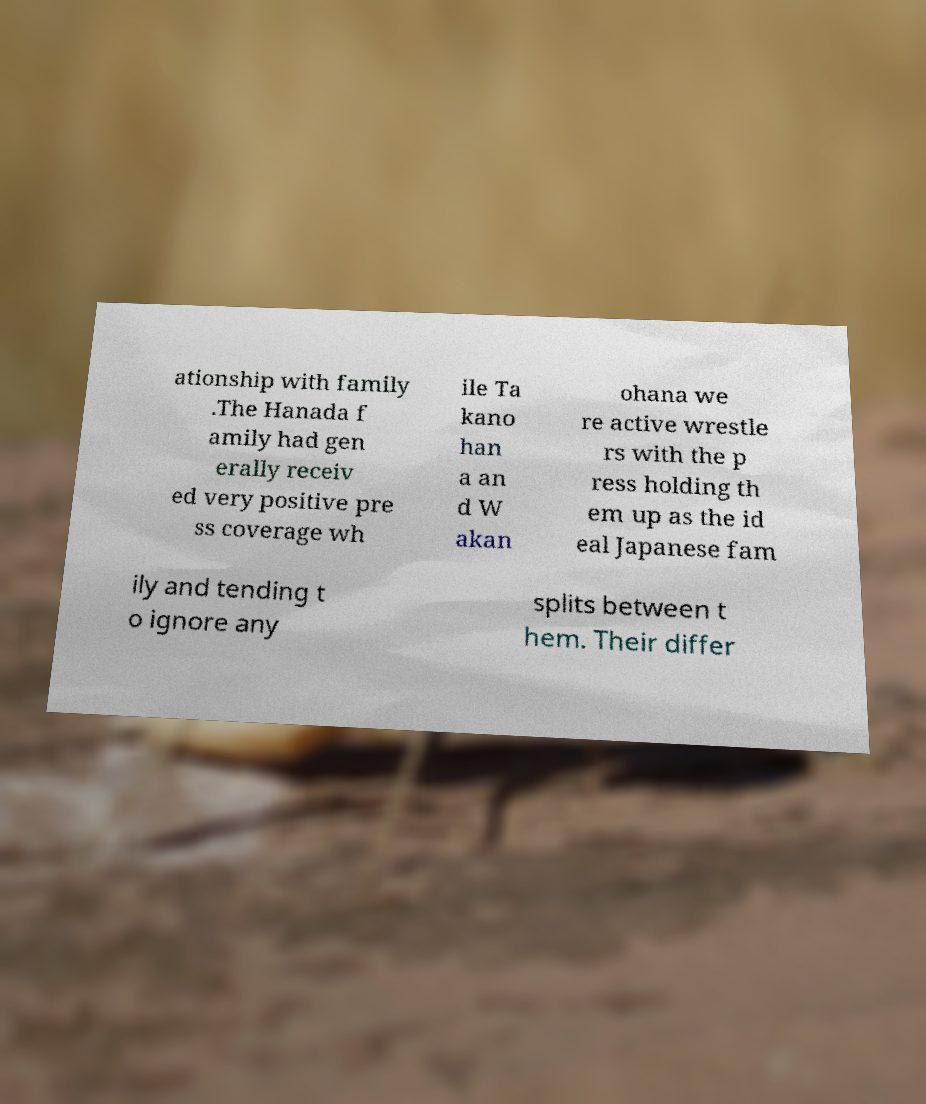What messages or text are displayed in this image? I need them in a readable, typed format. ationship with family .The Hanada f amily had gen erally receiv ed very positive pre ss coverage wh ile Ta kano han a an d W akan ohana we re active wrestle rs with the p ress holding th em up as the id eal Japanese fam ily and tending t o ignore any splits between t hem. Their differ 